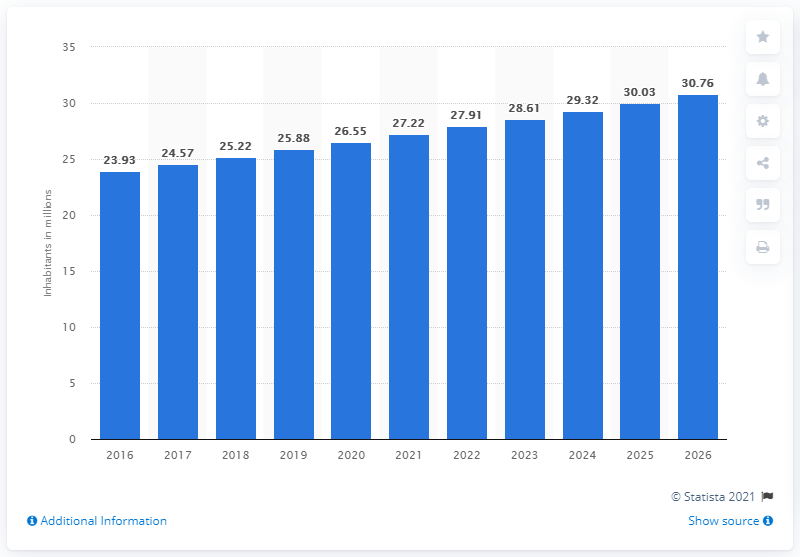Point out several critical features in this image. In 2020, the population of Cameroon was approximately 26.55 million people. 